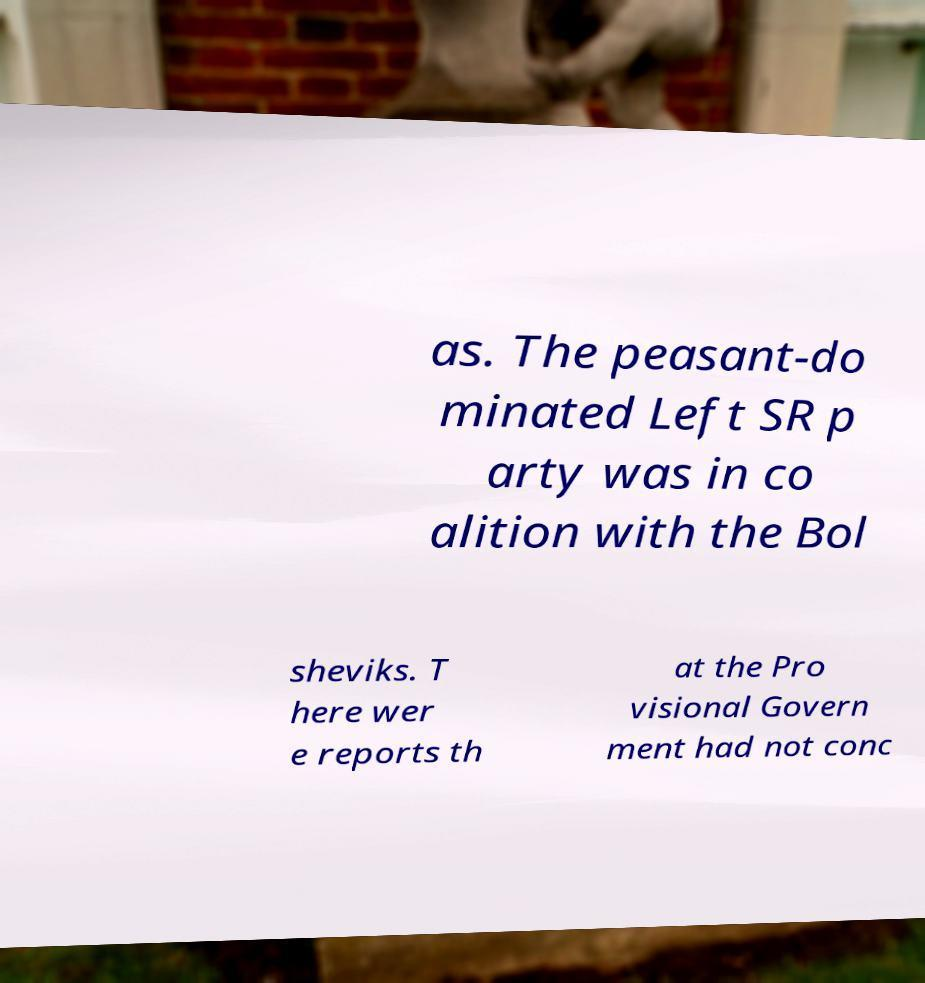Can you read and provide the text displayed in the image?This photo seems to have some interesting text. Can you extract and type it out for me? as. The peasant-do minated Left SR p arty was in co alition with the Bol sheviks. T here wer e reports th at the Pro visional Govern ment had not conc 